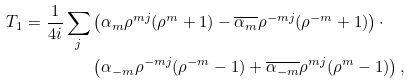Convert formula to latex. <formula><loc_0><loc_0><loc_500><loc_500>T _ { 1 } = \frac { 1 } { 4 i } \sum _ { j } & \left ( \alpha _ { m } \rho ^ { m j } ( \rho ^ { m } + 1 ) - \overline { \alpha _ { m } } \rho ^ { - m j } ( \rho ^ { - m } + 1 ) \right ) \cdot \\ & \left ( \alpha _ { - m } \rho ^ { - m j } ( \rho ^ { - m } - 1 ) + \overline { \alpha _ { - m } } \rho ^ { m j } ( \rho ^ { m } - 1 ) \right ) ,</formula> 